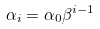Convert formula to latex. <formula><loc_0><loc_0><loc_500><loc_500>\alpha _ { i } = \alpha _ { 0 } \beta ^ { i - 1 }</formula> 